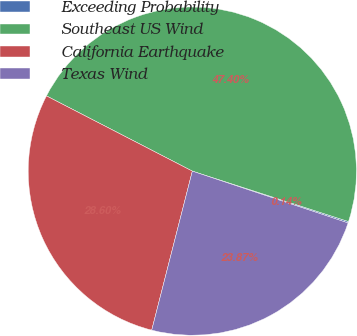Convert chart. <chart><loc_0><loc_0><loc_500><loc_500><pie_chart><fcel>Exceeding Probability<fcel>Southeast US Wind<fcel>California Earthquake<fcel>Texas Wind<nl><fcel>0.14%<fcel>47.4%<fcel>28.6%<fcel>23.87%<nl></chart> 